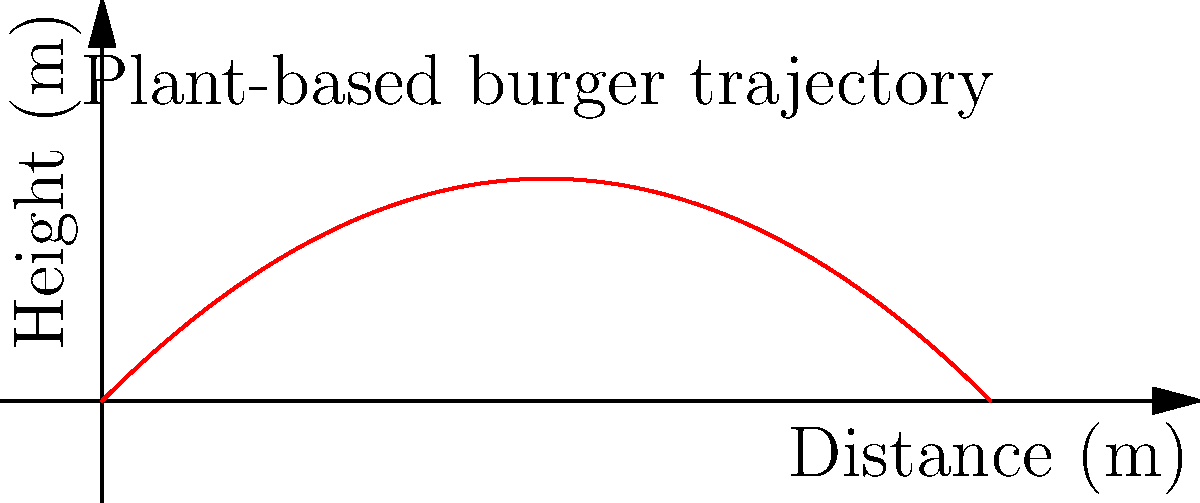A plant-based burger patty is thrown from ground level with an initial velocity of 10 m/s at an angle of 45° to the horizontal. Neglecting air resistance, what is the maximum height reached by the burger patty? To find the maximum height, we can follow these steps:

1. The vertical component of the initial velocity is:
   $v_{0y} = v_0 \sin \theta = 10 \cdot \sin 45° = 10 \cdot \frac{\sqrt{2}}{2} \approx 7.07$ m/s

2. At the highest point, the vertical velocity is zero. We can use the equation:
   $v_y^2 = v_{0y}^2 - 2gh_{max}$

3. Substituting $v_y = 0$ and solving for $h_{max}$:
   $0 = v_{0y}^2 - 2gh_{max}$
   $h_{max} = \frac{v_{0y}^2}{2g}$

4. Plugging in the values:
   $h_{max} = \frac{(7.07)^2}{2(9.8)} \approx 2.55$ m

Therefore, the maximum height reached by the plant-based burger patty is approximately 2.55 meters.
Answer: 2.55 m 